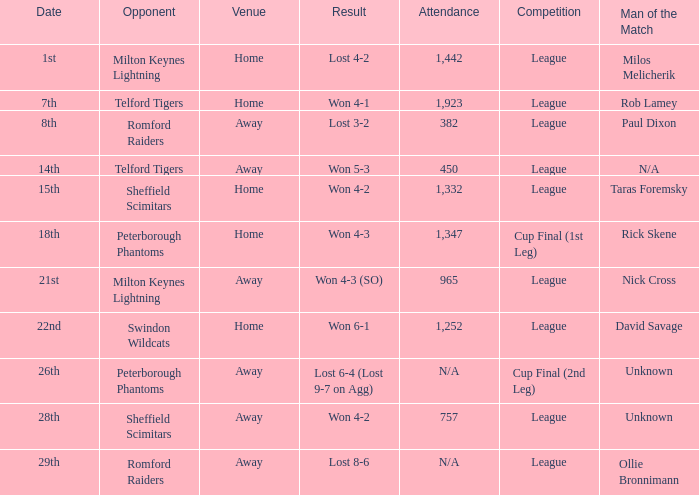What was the date when the opponent was Sheffield Scimitars and the venue was Home? 15th. 